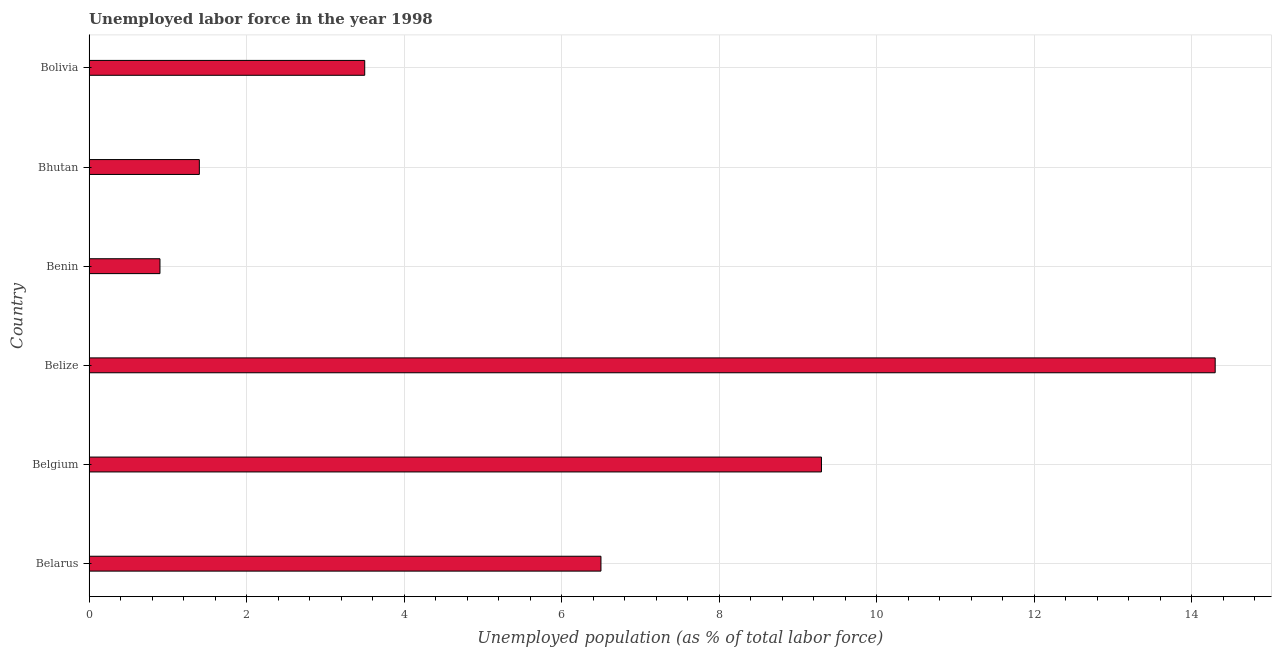Does the graph contain grids?
Keep it short and to the point. Yes. What is the title of the graph?
Ensure brevity in your answer.  Unemployed labor force in the year 1998. What is the label or title of the X-axis?
Your answer should be compact. Unemployed population (as % of total labor force). What is the total unemployed population in Belarus?
Your answer should be very brief. 6.5. Across all countries, what is the maximum total unemployed population?
Make the answer very short. 14.3. Across all countries, what is the minimum total unemployed population?
Your answer should be very brief. 0.9. In which country was the total unemployed population maximum?
Give a very brief answer. Belize. In which country was the total unemployed population minimum?
Provide a succinct answer. Benin. What is the sum of the total unemployed population?
Ensure brevity in your answer.  35.9. What is the difference between the total unemployed population in Bhutan and Bolivia?
Your response must be concise. -2.1. What is the average total unemployed population per country?
Your response must be concise. 5.98. What is the median total unemployed population?
Your response must be concise. 5. In how many countries, is the total unemployed population greater than 14.4 %?
Your response must be concise. 0. What is the ratio of the total unemployed population in Benin to that in Bolivia?
Keep it short and to the point. 0.26. Is the difference between the total unemployed population in Belarus and Bolivia greater than the difference between any two countries?
Your response must be concise. No. How many bars are there?
Make the answer very short. 6. Are all the bars in the graph horizontal?
Ensure brevity in your answer.  Yes. Are the values on the major ticks of X-axis written in scientific E-notation?
Your answer should be very brief. No. What is the Unemployed population (as % of total labor force) in Belgium?
Give a very brief answer. 9.3. What is the Unemployed population (as % of total labor force) of Belize?
Offer a very short reply. 14.3. What is the Unemployed population (as % of total labor force) in Benin?
Offer a terse response. 0.9. What is the Unemployed population (as % of total labor force) of Bhutan?
Give a very brief answer. 1.4. What is the difference between the Unemployed population (as % of total labor force) in Belarus and Benin?
Your response must be concise. 5.6. What is the difference between the Unemployed population (as % of total labor force) in Belarus and Bhutan?
Provide a succinct answer. 5.1. What is the difference between the Unemployed population (as % of total labor force) in Belgium and Benin?
Make the answer very short. 8.4. What is the difference between the Unemployed population (as % of total labor force) in Belgium and Bhutan?
Make the answer very short. 7.9. What is the difference between the Unemployed population (as % of total labor force) in Belgium and Bolivia?
Ensure brevity in your answer.  5.8. What is the difference between the Unemployed population (as % of total labor force) in Belize and Benin?
Keep it short and to the point. 13.4. What is the difference between the Unemployed population (as % of total labor force) in Belize and Bhutan?
Provide a succinct answer. 12.9. What is the difference between the Unemployed population (as % of total labor force) in Belize and Bolivia?
Provide a short and direct response. 10.8. What is the difference between the Unemployed population (as % of total labor force) in Benin and Bolivia?
Your response must be concise. -2.6. What is the ratio of the Unemployed population (as % of total labor force) in Belarus to that in Belgium?
Ensure brevity in your answer.  0.7. What is the ratio of the Unemployed population (as % of total labor force) in Belarus to that in Belize?
Give a very brief answer. 0.46. What is the ratio of the Unemployed population (as % of total labor force) in Belarus to that in Benin?
Offer a terse response. 7.22. What is the ratio of the Unemployed population (as % of total labor force) in Belarus to that in Bhutan?
Provide a short and direct response. 4.64. What is the ratio of the Unemployed population (as % of total labor force) in Belarus to that in Bolivia?
Your response must be concise. 1.86. What is the ratio of the Unemployed population (as % of total labor force) in Belgium to that in Belize?
Offer a terse response. 0.65. What is the ratio of the Unemployed population (as % of total labor force) in Belgium to that in Benin?
Your answer should be very brief. 10.33. What is the ratio of the Unemployed population (as % of total labor force) in Belgium to that in Bhutan?
Offer a very short reply. 6.64. What is the ratio of the Unemployed population (as % of total labor force) in Belgium to that in Bolivia?
Offer a very short reply. 2.66. What is the ratio of the Unemployed population (as % of total labor force) in Belize to that in Benin?
Make the answer very short. 15.89. What is the ratio of the Unemployed population (as % of total labor force) in Belize to that in Bhutan?
Offer a terse response. 10.21. What is the ratio of the Unemployed population (as % of total labor force) in Belize to that in Bolivia?
Your answer should be very brief. 4.09. What is the ratio of the Unemployed population (as % of total labor force) in Benin to that in Bhutan?
Provide a succinct answer. 0.64. What is the ratio of the Unemployed population (as % of total labor force) in Benin to that in Bolivia?
Provide a succinct answer. 0.26. 